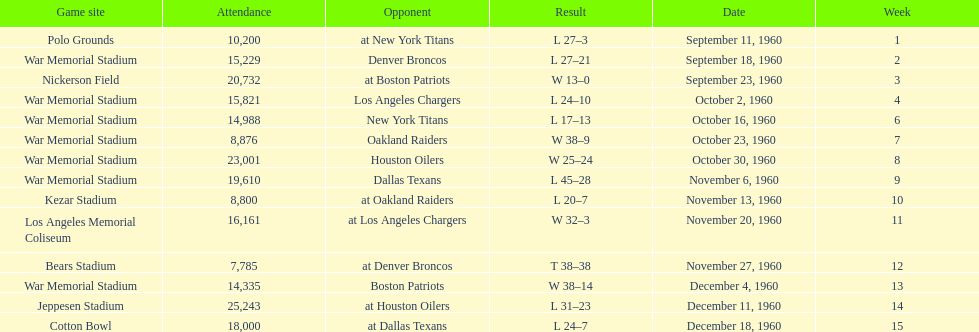Can you parse all the data within this table? {'header': ['Game site', 'Attendance', 'Opponent', 'Result', 'Date', 'Week'], 'rows': [['Polo Grounds', '10,200', 'at New York Titans', 'L 27–3', 'September 11, 1960', '1'], ['War Memorial Stadium', '15,229', 'Denver Broncos', 'L 27–21', 'September 18, 1960', '2'], ['Nickerson Field', '20,732', 'at Boston Patriots', 'W 13–0', 'September 23, 1960', '3'], ['War Memorial Stadium', '15,821', 'Los Angeles Chargers', 'L 24–10', 'October 2, 1960', '4'], ['War Memorial Stadium', '14,988', 'New York Titans', 'L 17–13', 'October 16, 1960', '6'], ['War Memorial Stadium', '8,876', 'Oakland Raiders', 'W 38–9', 'October 23, 1960', '7'], ['War Memorial Stadium', '23,001', 'Houston Oilers', 'W 25–24', 'October 30, 1960', '8'], ['War Memorial Stadium', '19,610', 'Dallas Texans', 'L 45–28', 'November 6, 1960', '9'], ['Kezar Stadium', '8,800', 'at Oakland Raiders', 'L 20–7', 'November 13, 1960', '10'], ['Los Angeles Memorial Coliseum', '16,161', 'at Los Angeles Chargers', 'W 32–3', 'November 20, 1960', '11'], ['Bears Stadium', '7,785', 'at Denver Broncos', 'T 38–38', 'November 27, 1960', '12'], ['War Memorial Stadium', '14,335', 'Boston Patriots', 'W 38–14', 'December 4, 1960', '13'], ['Jeppesen Stadium', '25,243', 'at Houston Oilers', 'L 31–23', 'December 11, 1960', '14'], ['Cotton Bowl', '18,000', 'at Dallas Texans', 'L 24–7', 'December 18, 1960', '15']]} The total number of games played at war memorial stadium was how many? 7. 